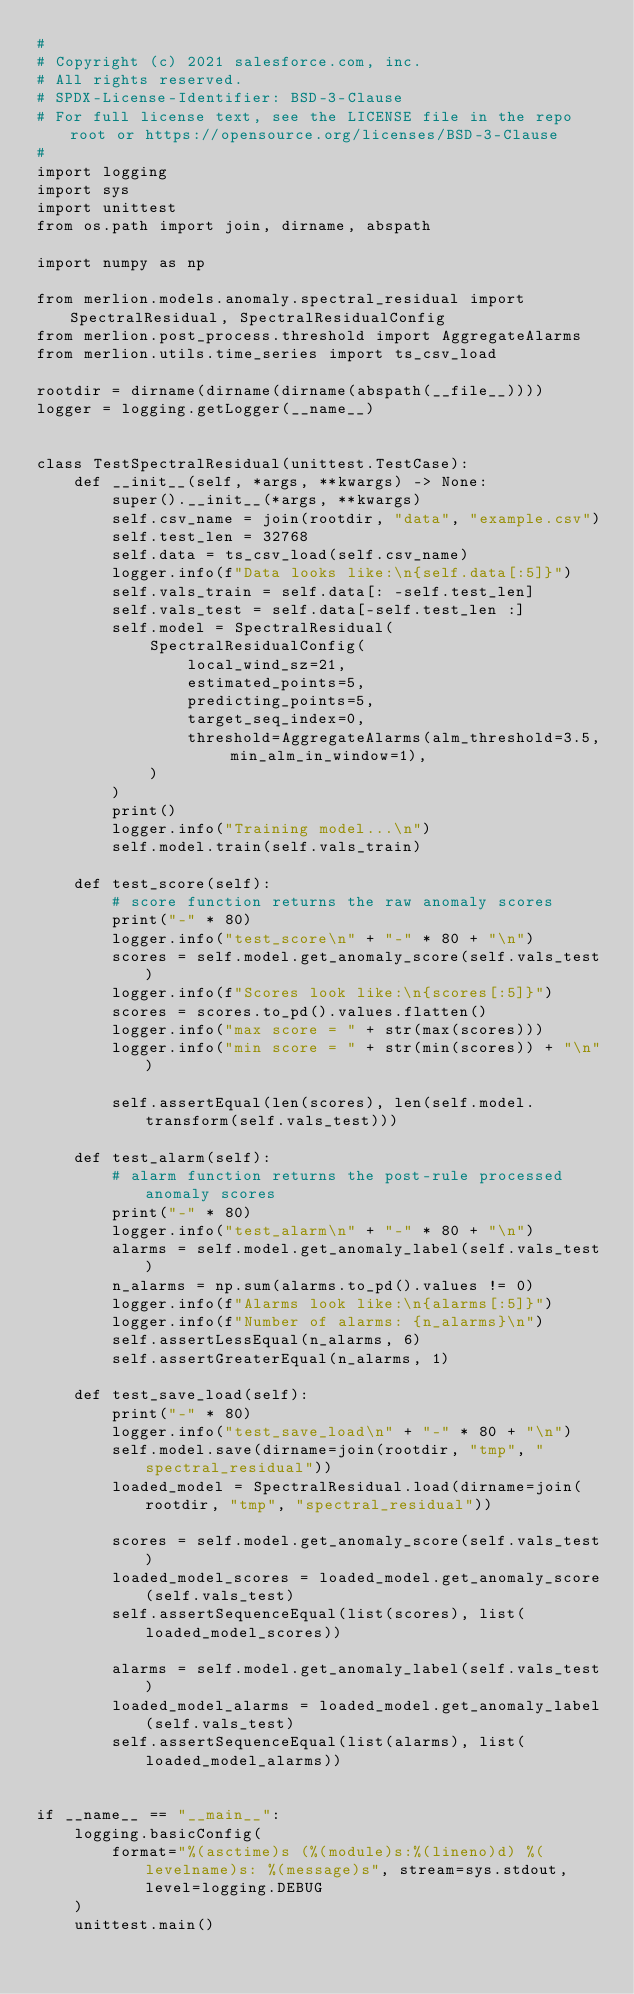<code> <loc_0><loc_0><loc_500><loc_500><_Python_>#
# Copyright (c) 2021 salesforce.com, inc.
# All rights reserved.
# SPDX-License-Identifier: BSD-3-Clause
# For full license text, see the LICENSE file in the repo root or https://opensource.org/licenses/BSD-3-Clause
#
import logging
import sys
import unittest
from os.path import join, dirname, abspath

import numpy as np

from merlion.models.anomaly.spectral_residual import SpectralResidual, SpectralResidualConfig
from merlion.post_process.threshold import AggregateAlarms
from merlion.utils.time_series import ts_csv_load

rootdir = dirname(dirname(dirname(abspath(__file__))))
logger = logging.getLogger(__name__)


class TestSpectralResidual(unittest.TestCase):
    def __init__(self, *args, **kwargs) -> None:
        super().__init__(*args, **kwargs)
        self.csv_name = join(rootdir, "data", "example.csv")
        self.test_len = 32768
        self.data = ts_csv_load(self.csv_name)
        logger.info(f"Data looks like:\n{self.data[:5]}")
        self.vals_train = self.data[: -self.test_len]
        self.vals_test = self.data[-self.test_len :]
        self.model = SpectralResidual(
            SpectralResidualConfig(
                local_wind_sz=21,
                estimated_points=5,
                predicting_points=5,
                target_seq_index=0,
                threshold=AggregateAlarms(alm_threshold=3.5, min_alm_in_window=1),
            )
        )
        print()
        logger.info("Training model...\n")
        self.model.train(self.vals_train)

    def test_score(self):
        # score function returns the raw anomaly scores
        print("-" * 80)
        logger.info("test_score\n" + "-" * 80 + "\n")
        scores = self.model.get_anomaly_score(self.vals_test)
        logger.info(f"Scores look like:\n{scores[:5]}")
        scores = scores.to_pd().values.flatten()
        logger.info("max score = " + str(max(scores)))
        logger.info("min score = " + str(min(scores)) + "\n")

        self.assertEqual(len(scores), len(self.model.transform(self.vals_test)))

    def test_alarm(self):
        # alarm function returns the post-rule processed anomaly scores
        print("-" * 80)
        logger.info("test_alarm\n" + "-" * 80 + "\n")
        alarms = self.model.get_anomaly_label(self.vals_test)
        n_alarms = np.sum(alarms.to_pd().values != 0)
        logger.info(f"Alarms look like:\n{alarms[:5]}")
        logger.info(f"Number of alarms: {n_alarms}\n")
        self.assertLessEqual(n_alarms, 6)
        self.assertGreaterEqual(n_alarms, 1)

    def test_save_load(self):
        print("-" * 80)
        logger.info("test_save_load\n" + "-" * 80 + "\n")
        self.model.save(dirname=join(rootdir, "tmp", "spectral_residual"))
        loaded_model = SpectralResidual.load(dirname=join(rootdir, "tmp", "spectral_residual"))

        scores = self.model.get_anomaly_score(self.vals_test)
        loaded_model_scores = loaded_model.get_anomaly_score(self.vals_test)
        self.assertSequenceEqual(list(scores), list(loaded_model_scores))

        alarms = self.model.get_anomaly_label(self.vals_test)
        loaded_model_alarms = loaded_model.get_anomaly_label(self.vals_test)
        self.assertSequenceEqual(list(alarms), list(loaded_model_alarms))


if __name__ == "__main__":
    logging.basicConfig(
        format="%(asctime)s (%(module)s:%(lineno)d) %(levelname)s: %(message)s", stream=sys.stdout, level=logging.DEBUG
    )
    unittest.main()
</code> 